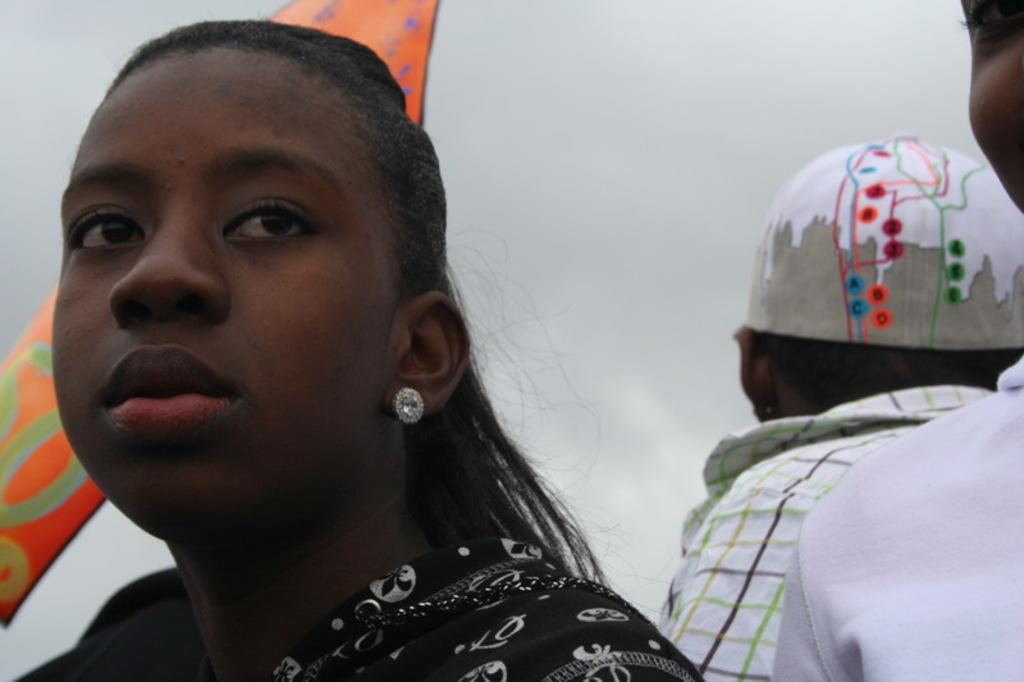What is the main subject of the image? There is a lady person in the image. Can you describe the lady person's attire? The lady person is wearing a black dress. Are there any other people in the image? Yes, there are other persons standing in the image. What type of plants can be seen growing near the gate in the image? There is no gate or plants present in the image. What kind of food is the lady person holding in the image? There is no food visible in the image. 